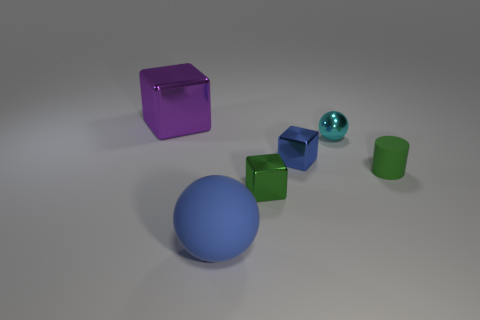Add 2 tiny cyan balls. How many objects exist? 8 Subtract all tiny cubes. How many cubes are left? 1 Subtract all cylinders. How many objects are left? 5 Add 4 green cylinders. How many green cylinders are left? 5 Add 4 small purple matte balls. How many small purple matte balls exist? 4 Subtract 0 purple spheres. How many objects are left? 6 Subtract all cylinders. Subtract all tiny things. How many objects are left? 1 